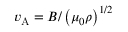Convert formula to latex. <formula><loc_0><loc_0><loc_500><loc_500>v _ { A } = B / \left ( \mu _ { 0 } \rho \right ) ^ { 1 / 2 }</formula> 